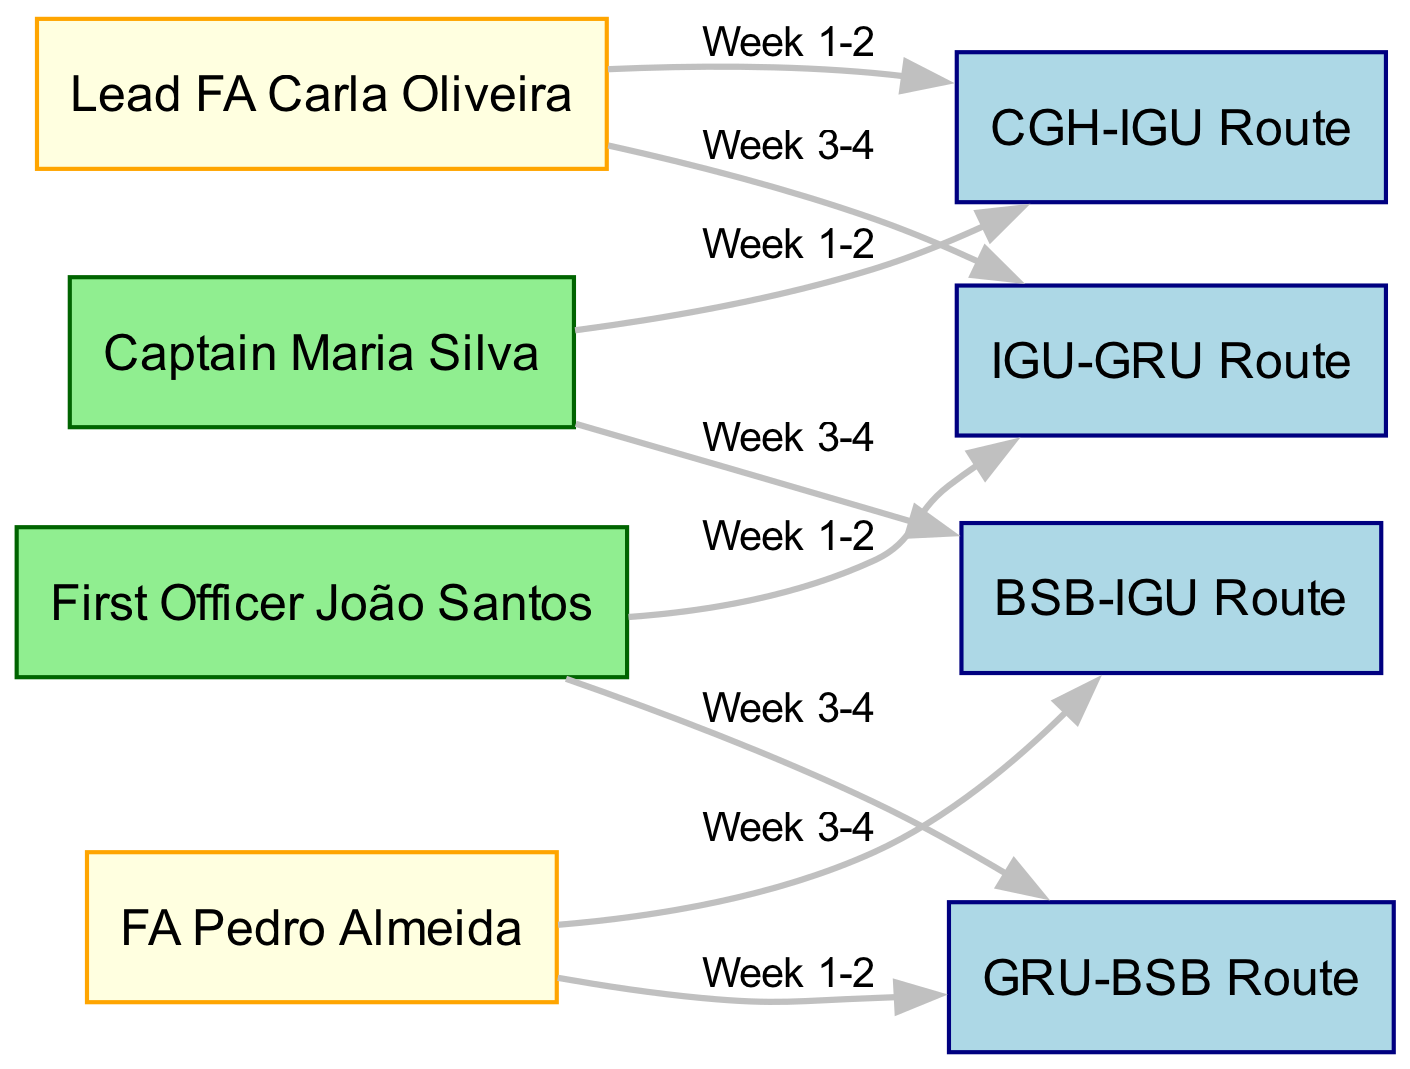What are the two roles represented in the diagram? The diagram includes two roles: Captain and Flight Attendant (FA). These represent the different positions in the flight crew rotation schedule.
Answer: Captain, Flight Attendant Which route is assigned to Captain Maria Silva in weeks 1-2? Captain Maria Silva is assigned to the CGH-IGU Route during weeks 1-2, as indicated by the directed edge in the diagram.
Answer: CGH-IGU Route How many flight attendants are assigned different routes? Two flight attendants are assigned to different routes: Lead FA Carla Oliveira and FA Pedro Almeida, as per the distinct edges leading from them to the routes.
Answer: 2 What is the last route to which FA Pedro Almeida is assigned? The last route assigned to FA Pedro Almeida is the BSB-IGU Route, as per the directed edge flowing from FA Pedro Almeida to that route.
Answer: BSB-IGU Route Which officer is assigned to the GRU-BSB Route in weeks 3-4? The officer assigned to the GRU-BSB Route in weeks 3-4 is First Officer João Santos, according to the directed edge from him to that route.
Answer: First Officer João Santos How many total edges are in the diagram? The diagram contains a total of 8 edges, which represent the assignments of crew members to routes over the weeks.
Answer: 8 Is Lead FA Carla Oliveira assigned to the BSB-IGU Route in the first two weeks? No, Lead FA Carla Oliveira is not assigned to the BSB-IGU Route in the first two weeks; she is assigned to CGH-IGU Route during that time.
Answer: No Which route does the Last assigned crew member work on in week 3-4? The last assigned route in week 3-4 is BSB-IGU Route, which is assigned to FA Pedro Almeida as per the directed edge in the diagram.
Answer: BSB-IGU Route 